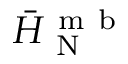<formula> <loc_0><loc_0><loc_500><loc_500>\ B a r { H } _ { N } ^ { m b }</formula> 